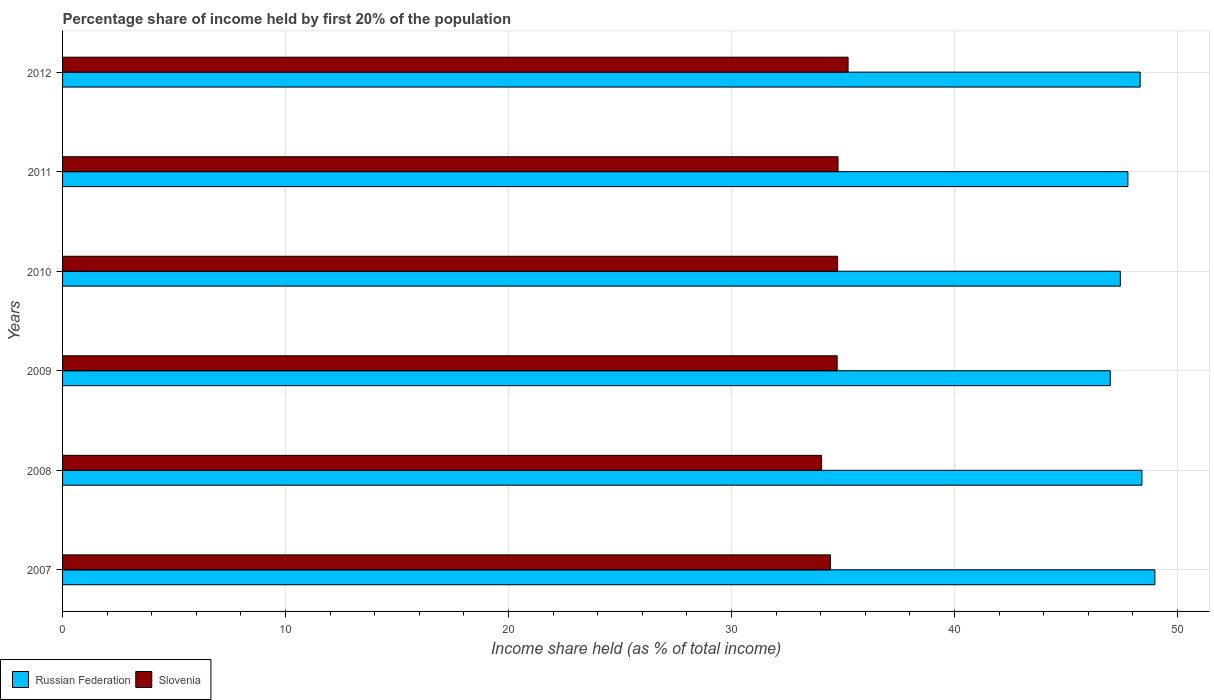Are the number of bars per tick equal to the number of legend labels?
Provide a succinct answer. Yes. In how many cases, is the number of bars for a given year not equal to the number of legend labels?
Make the answer very short. 0. What is the share of income held by first 20% of the population in Russian Federation in 2011?
Your answer should be compact. 47.78. Across all years, what is the maximum share of income held by first 20% of the population in Russian Federation?
Your response must be concise. 48.99. Across all years, what is the minimum share of income held by first 20% of the population in Slovenia?
Your answer should be compact. 34.04. In which year was the share of income held by first 20% of the population in Russian Federation maximum?
Provide a short and direct response. 2007. What is the total share of income held by first 20% of the population in Slovenia in the graph?
Ensure brevity in your answer.  207.99. What is the difference between the share of income held by first 20% of the population in Slovenia in 2008 and that in 2011?
Offer a terse response. -0.74. What is the difference between the share of income held by first 20% of the population in Slovenia in 2008 and the share of income held by first 20% of the population in Russian Federation in 2007?
Your answer should be compact. -14.95. What is the average share of income held by first 20% of the population in Russian Federation per year?
Offer a very short reply. 47.99. In the year 2012, what is the difference between the share of income held by first 20% of the population in Russian Federation and share of income held by first 20% of the population in Slovenia?
Your answer should be compact. 13.1. What is the ratio of the share of income held by first 20% of the population in Slovenia in 2010 to that in 2012?
Provide a short and direct response. 0.99. Is the difference between the share of income held by first 20% of the population in Russian Federation in 2010 and 2011 greater than the difference between the share of income held by first 20% of the population in Slovenia in 2010 and 2011?
Ensure brevity in your answer.  No. What is the difference between the highest and the second highest share of income held by first 20% of the population in Russian Federation?
Keep it short and to the point. 0.58. What is the difference between the highest and the lowest share of income held by first 20% of the population in Russian Federation?
Your response must be concise. 2. In how many years, is the share of income held by first 20% of the population in Russian Federation greater than the average share of income held by first 20% of the population in Russian Federation taken over all years?
Your answer should be compact. 3. What does the 2nd bar from the top in 2007 represents?
Offer a very short reply. Russian Federation. What does the 2nd bar from the bottom in 2012 represents?
Provide a short and direct response. Slovenia. Are all the bars in the graph horizontal?
Your response must be concise. Yes. What is the difference between two consecutive major ticks on the X-axis?
Provide a succinct answer. 10. Are the values on the major ticks of X-axis written in scientific E-notation?
Ensure brevity in your answer.  No. Does the graph contain any zero values?
Provide a succinct answer. No. Does the graph contain grids?
Make the answer very short. Yes. What is the title of the graph?
Provide a short and direct response. Percentage share of income held by first 20% of the population. What is the label or title of the X-axis?
Provide a succinct answer. Income share held (as % of total income). What is the Income share held (as % of total income) of Russian Federation in 2007?
Make the answer very short. 48.99. What is the Income share held (as % of total income) in Slovenia in 2007?
Your answer should be very brief. 34.44. What is the Income share held (as % of total income) in Russian Federation in 2008?
Offer a terse response. 48.41. What is the Income share held (as % of total income) in Slovenia in 2008?
Make the answer very short. 34.04. What is the Income share held (as % of total income) of Russian Federation in 2009?
Your answer should be compact. 46.99. What is the Income share held (as % of total income) in Slovenia in 2009?
Ensure brevity in your answer.  34.74. What is the Income share held (as % of total income) of Russian Federation in 2010?
Your answer should be compact. 47.44. What is the Income share held (as % of total income) of Slovenia in 2010?
Your response must be concise. 34.76. What is the Income share held (as % of total income) in Russian Federation in 2011?
Your answer should be very brief. 47.78. What is the Income share held (as % of total income) of Slovenia in 2011?
Keep it short and to the point. 34.78. What is the Income share held (as % of total income) of Russian Federation in 2012?
Your response must be concise. 48.33. What is the Income share held (as % of total income) of Slovenia in 2012?
Make the answer very short. 35.23. Across all years, what is the maximum Income share held (as % of total income) of Russian Federation?
Provide a succinct answer. 48.99. Across all years, what is the maximum Income share held (as % of total income) of Slovenia?
Ensure brevity in your answer.  35.23. Across all years, what is the minimum Income share held (as % of total income) in Russian Federation?
Keep it short and to the point. 46.99. Across all years, what is the minimum Income share held (as % of total income) of Slovenia?
Make the answer very short. 34.04. What is the total Income share held (as % of total income) in Russian Federation in the graph?
Keep it short and to the point. 287.94. What is the total Income share held (as % of total income) in Slovenia in the graph?
Give a very brief answer. 207.99. What is the difference between the Income share held (as % of total income) in Russian Federation in 2007 and that in 2008?
Your answer should be compact. 0.58. What is the difference between the Income share held (as % of total income) of Russian Federation in 2007 and that in 2009?
Make the answer very short. 2. What is the difference between the Income share held (as % of total income) in Slovenia in 2007 and that in 2009?
Provide a succinct answer. -0.3. What is the difference between the Income share held (as % of total income) in Russian Federation in 2007 and that in 2010?
Give a very brief answer. 1.55. What is the difference between the Income share held (as % of total income) of Slovenia in 2007 and that in 2010?
Ensure brevity in your answer.  -0.32. What is the difference between the Income share held (as % of total income) of Russian Federation in 2007 and that in 2011?
Your answer should be compact. 1.21. What is the difference between the Income share held (as % of total income) of Slovenia in 2007 and that in 2011?
Your response must be concise. -0.34. What is the difference between the Income share held (as % of total income) of Russian Federation in 2007 and that in 2012?
Your answer should be compact. 0.66. What is the difference between the Income share held (as % of total income) in Slovenia in 2007 and that in 2012?
Offer a terse response. -0.79. What is the difference between the Income share held (as % of total income) in Russian Federation in 2008 and that in 2009?
Your response must be concise. 1.42. What is the difference between the Income share held (as % of total income) of Slovenia in 2008 and that in 2010?
Make the answer very short. -0.72. What is the difference between the Income share held (as % of total income) in Russian Federation in 2008 and that in 2011?
Your answer should be very brief. 0.63. What is the difference between the Income share held (as % of total income) in Slovenia in 2008 and that in 2011?
Keep it short and to the point. -0.74. What is the difference between the Income share held (as % of total income) in Russian Federation in 2008 and that in 2012?
Provide a short and direct response. 0.08. What is the difference between the Income share held (as % of total income) of Slovenia in 2008 and that in 2012?
Your response must be concise. -1.19. What is the difference between the Income share held (as % of total income) in Russian Federation in 2009 and that in 2010?
Provide a short and direct response. -0.45. What is the difference between the Income share held (as % of total income) of Slovenia in 2009 and that in 2010?
Ensure brevity in your answer.  -0.02. What is the difference between the Income share held (as % of total income) in Russian Federation in 2009 and that in 2011?
Your response must be concise. -0.79. What is the difference between the Income share held (as % of total income) in Slovenia in 2009 and that in 2011?
Give a very brief answer. -0.04. What is the difference between the Income share held (as % of total income) of Russian Federation in 2009 and that in 2012?
Keep it short and to the point. -1.34. What is the difference between the Income share held (as % of total income) in Slovenia in 2009 and that in 2012?
Provide a short and direct response. -0.49. What is the difference between the Income share held (as % of total income) in Russian Federation in 2010 and that in 2011?
Your answer should be compact. -0.34. What is the difference between the Income share held (as % of total income) in Slovenia in 2010 and that in 2011?
Your answer should be compact. -0.02. What is the difference between the Income share held (as % of total income) in Russian Federation in 2010 and that in 2012?
Keep it short and to the point. -0.89. What is the difference between the Income share held (as % of total income) in Slovenia in 2010 and that in 2012?
Provide a short and direct response. -0.47. What is the difference between the Income share held (as % of total income) of Russian Federation in 2011 and that in 2012?
Offer a terse response. -0.55. What is the difference between the Income share held (as % of total income) in Slovenia in 2011 and that in 2012?
Give a very brief answer. -0.45. What is the difference between the Income share held (as % of total income) in Russian Federation in 2007 and the Income share held (as % of total income) in Slovenia in 2008?
Your answer should be very brief. 14.95. What is the difference between the Income share held (as % of total income) in Russian Federation in 2007 and the Income share held (as % of total income) in Slovenia in 2009?
Your answer should be very brief. 14.25. What is the difference between the Income share held (as % of total income) in Russian Federation in 2007 and the Income share held (as % of total income) in Slovenia in 2010?
Your response must be concise. 14.23. What is the difference between the Income share held (as % of total income) of Russian Federation in 2007 and the Income share held (as % of total income) of Slovenia in 2011?
Offer a very short reply. 14.21. What is the difference between the Income share held (as % of total income) in Russian Federation in 2007 and the Income share held (as % of total income) in Slovenia in 2012?
Make the answer very short. 13.76. What is the difference between the Income share held (as % of total income) in Russian Federation in 2008 and the Income share held (as % of total income) in Slovenia in 2009?
Provide a short and direct response. 13.67. What is the difference between the Income share held (as % of total income) in Russian Federation in 2008 and the Income share held (as % of total income) in Slovenia in 2010?
Give a very brief answer. 13.65. What is the difference between the Income share held (as % of total income) in Russian Federation in 2008 and the Income share held (as % of total income) in Slovenia in 2011?
Provide a short and direct response. 13.63. What is the difference between the Income share held (as % of total income) in Russian Federation in 2008 and the Income share held (as % of total income) in Slovenia in 2012?
Make the answer very short. 13.18. What is the difference between the Income share held (as % of total income) in Russian Federation in 2009 and the Income share held (as % of total income) in Slovenia in 2010?
Ensure brevity in your answer.  12.23. What is the difference between the Income share held (as % of total income) of Russian Federation in 2009 and the Income share held (as % of total income) of Slovenia in 2011?
Your answer should be very brief. 12.21. What is the difference between the Income share held (as % of total income) of Russian Federation in 2009 and the Income share held (as % of total income) of Slovenia in 2012?
Ensure brevity in your answer.  11.76. What is the difference between the Income share held (as % of total income) in Russian Federation in 2010 and the Income share held (as % of total income) in Slovenia in 2011?
Give a very brief answer. 12.66. What is the difference between the Income share held (as % of total income) of Russian Federation in 2010 and the Income share held (as % of total income) of Slovenia in 2012?
Your answer should be compact. 12.21. What is the difference between the Income share held (as % of total income) in Russian Federation in 2011 and the Income share held (as % of total income) in Slovenia in 2012?
Offer a very short reply. 12.55. What is the average Income share held (as % of total income) of Russian Federation per year?
Provide a succinct answer. 47.99. What is the average Income share held (as % of total income) in Slovenia per year?
Your response must be concise. 34.66. In the year 2007, what is the difference between the Income share held (as % of total income) in Russian Federation and Income share held (as % of total income) in Slovenia?
Your answer should be very brief. 14.55. In the year 2008, what is the difference between the Income share held (as % of total income) in Russian Federation and Income share held (as % of total income) in Slovenia?
Make the answer very short. 14.37. In the year 2009, what is the difference between the Income share held (as % of total income) of Russian Federation and Income share held (as % of total income) of Slovenia?
Provide a succinct answer. 12.25. In the year 2010, what is the difference between the Income share held (as % of total income) in Russian Federation and Income share held (as % of total income) in Slovenia?
Provide a succinct answer. 12.68. What is the ratio of the Income share held (as % of total income) of Slovenia in 2007 to that in 2008?
Your answer should be compact. 1.01. What is the ratio of the Income share held (as % of total income) of Russian Federation in 2007 to that in 2009?
Provide a succinct answer. 1.04. What is the ratio of the Income share held (as % of total income) in Russian Federation in 2007 to that in 2010?
Provide a short and direct response. 1.03. What is the ratio of the Income share held (as % of total income) of Russian Federation in 2007 to that in 2011?
Your answer should be compact. 1.03. What is the ratio of the Income share held (as % of total income) of Slovenia in 2007 to that in 2011?
Provide a succinct answer. 0.99. What is the ratio of the Income share held (as % of total income) in Russian Federation in 2007 to that in 2012?
Provide a succinct answer. 1.01. What is the ratio of the Income share held (as % of total income) in Slovenia in 2007 to that in 2012?
Your answer should be compact. 0.98. What is the ratio of the Income share held (as % of total income) in Russian Federation in 2008 to that in 2009?
Keep it short and to the point. 1.03. What is the ratio of the Income share held (as % of total income) of Slovenia in 2008 to that in 2009?
Offer a very short reply. 0.98. What is the ratio of the Income share held (as % of total income) of Russian Federation in 2008 to that in 2010?
Give a very brief answer. 1.02. What is the ratio of the Income share held (as % of total income) in Slovenia in 2008 to that in 2010?
Your answer should be very brief. 0.98. What is the ratio of the Income share held (as % of total income) in Russian Federation in 2008 to that in 2011?
Ensure brevity in your answer.  1.01. What is the ratio of the Income share held (as % of total income) of Slovenia in 2008 to that in 2011?
Offer a very short reply. 0.98. What is the ratio of the Income share held (as % of total income) of Russian Federation in 2008 to that in 2012?
Your response must be concise. 1. What is the ratio of the Income share held (as % of total income) of Slovenia in 2008 to that in 2012?
Provide a succinct answer. 0.97. What is the ratio of the Income share held (as % of total income) of Russian Federation in 2009 to that in 2011?
Make the answer very short. 0.98. What is the ratio of the Income share held (as % of total income) of Slovenia in 2009 to that in 2011?
Your answer should be compact. 1. What is the ratio of the Income share held (as % of total income) of Russian Federation in 2009 to that in 2012?
Your answer should be compact. 0.97. What is the ratio of the Income share held (as % of total income) in Slovenia in 2009 to that in 2012?
Make the answer very short. 0.99. What is the ratio of the Income share held (as % of total income) in Russian Federation in 2010 to that in 2011?
Make the answer very short. 0.99. What is the ratio of the Income share held (as % of total income) in Slovenia in 2010 to that in 2011?
Your response must be concise. 1. What is the ratio of the Income share held (as % of total income) of Russian Federation in 2010 to that in 2012?
Your answer should be compact. 0.98. What is the ratio of the Income share held (as % of total income) in Slovenia in 2010 to that in 2012?
Provide a succinct answer. 0.99. What is the ratio of the Income share held (as % of total income) of Russian Federation in 2011 to that in 2012?
Provide a short and direct response. 0.99. What is the ratio of the Income share held (as % of total income) in Slovenia in 2011 to that in 2012?
Make the answer very short. 0.99. What is the difference between the highest and the second highest Income share held (as % of total income) in Russian Federation?
Provide a succinct answer. 0.58. What is the difference between the highest and the second highest Income share held (as % of total income) in Slovenia?
Offer a very short reply. 0.45. What is the difference between the highest and the lowest Income share held (as % of total income) of Slovenia?
Keep it short and to the point. 1.19. 